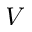Convert formula to latex. <formula><loc_0><loc_0><loc_500><loc_500>V</formula> 